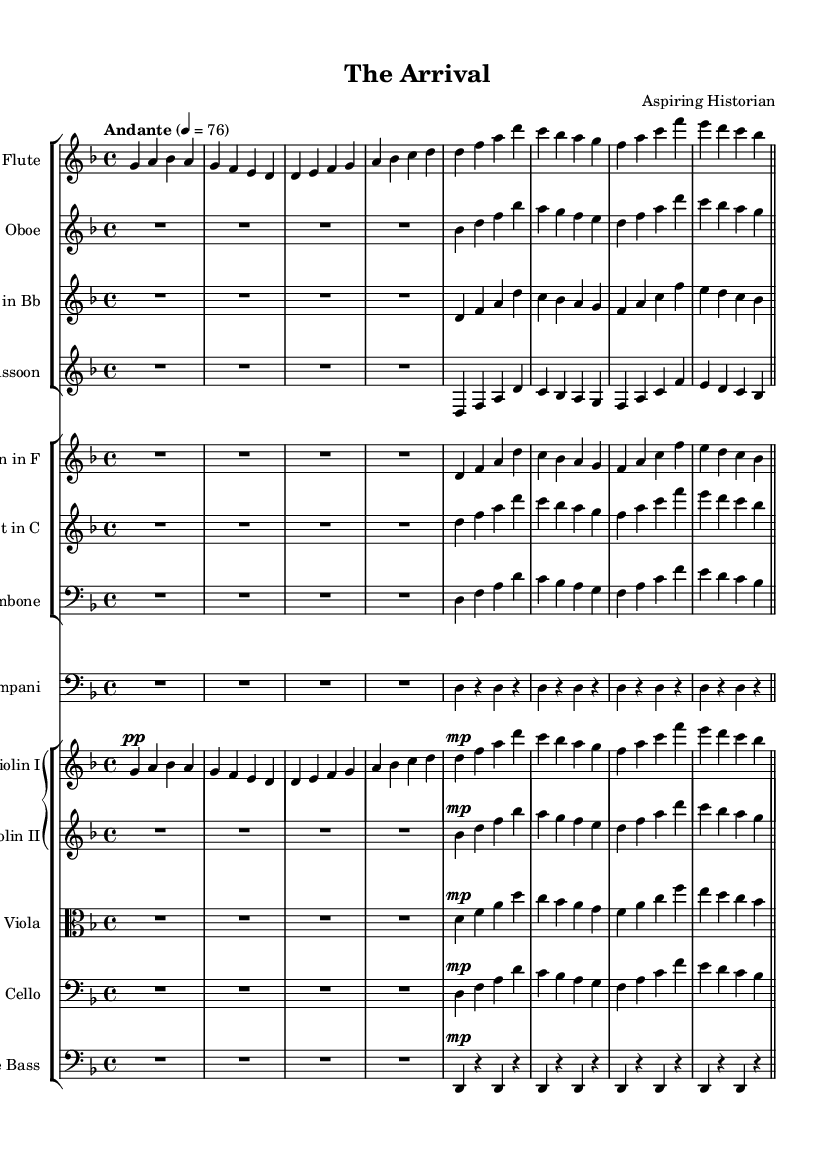What is the key signature of this music? The key signature is indicated at the beginning of the staff and shows one flat, which corresponds to the key of D minor.
Answer: D minor What is the time signature of this music? The time signature is found at the beginning and indicates four beats per measure, which is shown as "4/4".
Answer: 4/4 What is the tempo marking of this symphony? The tempo marking appears at the beginning and indicates the tempo as "Andante" with a metronome marking of quarter note = 76.
Answer: Andante How many measures are in the flute part? By counting the bars in the flute part, there are a total of 8 measures present, ending with the double bar line.
Answer: 8 Which instruments have rests in their parts? Rests are indicated in the sheet music for instruments like the Oboe, Clarinet, and Timpani, particularly at the start of their respective sections.
Answer: Oboe, Clarinet, Timpani What dynamic markings are present in the violin parts? The dynamic markings can be found in the violin parts, with Violin I starting with "pp" (pianissimo) and switching to "mp" (mezzo piano) later.
Answer: pp, mp What is the instrumentation of this symphony? The instrumentation is shown through the various staves listed, including Flute, Oboe, Clarinet, Bassoon, Horn, Trumpet, Trombone, Timpani, and strings (Violin I, Violin II, Viola, Cello, Double Bass).
Answer: Flute, Oboe, Clarinet, Bassoon, Horn, Trumpet, Trombone, Timpani, Violin I, Violin II, Viola, Cello, Double Bass 